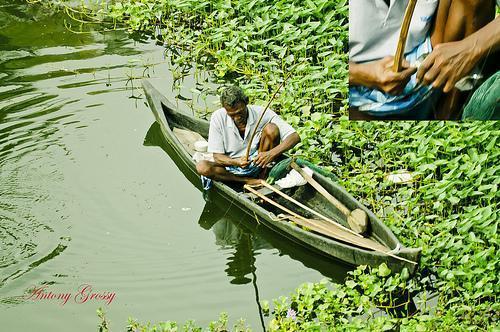How many people are seen in the picture?
Give a very brief answer. 1. 